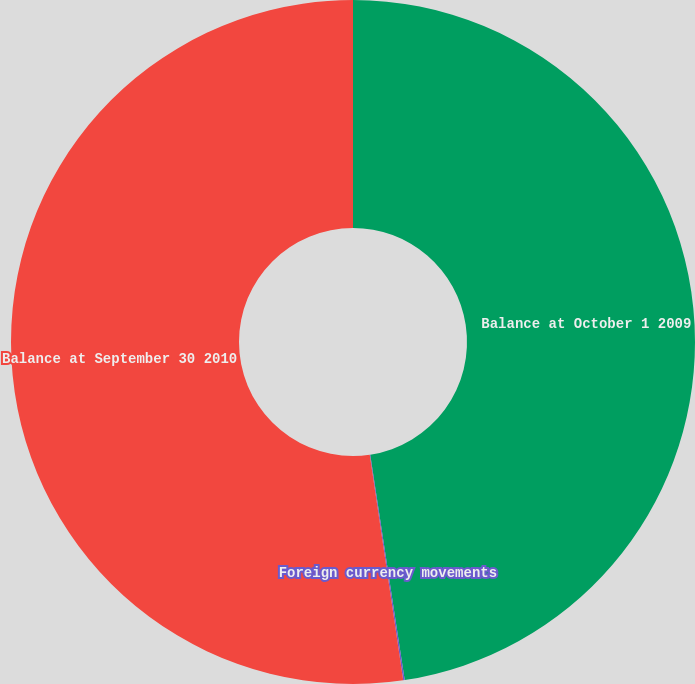Convert chart. <chart><loc_0><loc_0><loc_500><loc_500><pie_chart><fcel>Balance at October 1 2009<fcel>Foreign currency movements<fcel>Balance at September 30 2010<nl><fcel>47.58%<fcel>0.07%<fcel>52.34%<nl></chart> 